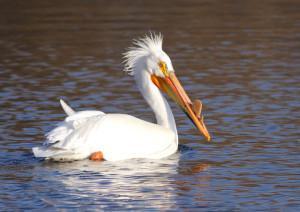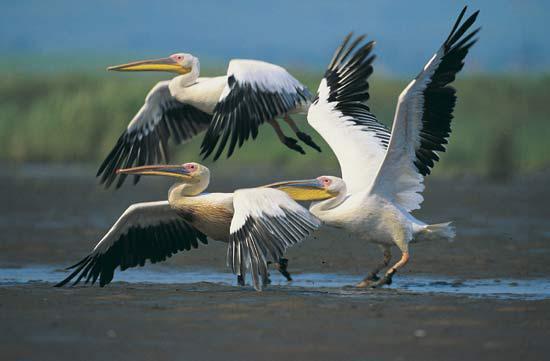The first image is the image on the left, the second image is the image on the right. Evaluate the accuracy of this statement regarding the images: "At least one bird is sitting on water.". Is it true? Answer yes or no. Yes. 